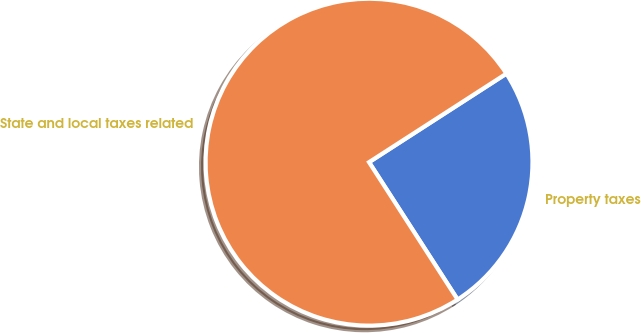<chart> <loc_0><loc_0><loc_500><loc_500><pie_chart><fcel>Property taxes<fcel>State and local taxes related<nl><fcel>25.0%<fcel>75.0%<nl></chart> 